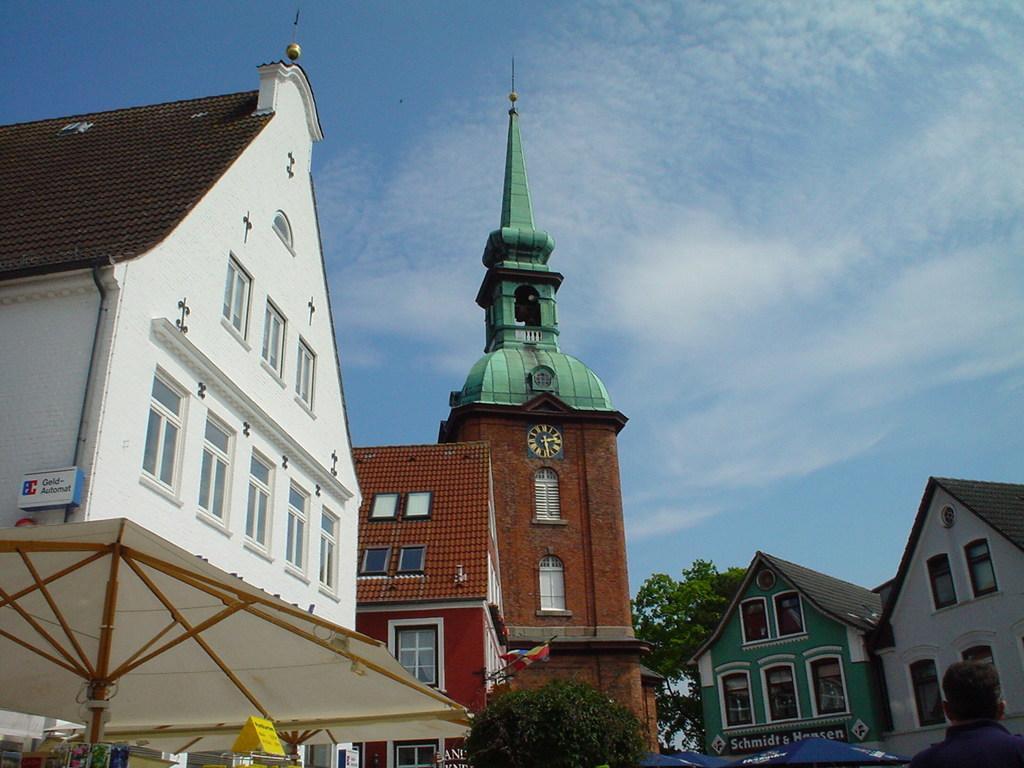Please provide a concise description of this image. In this image I can see few buildings. I can see two trees. At the top I can see clouds in the sky. 